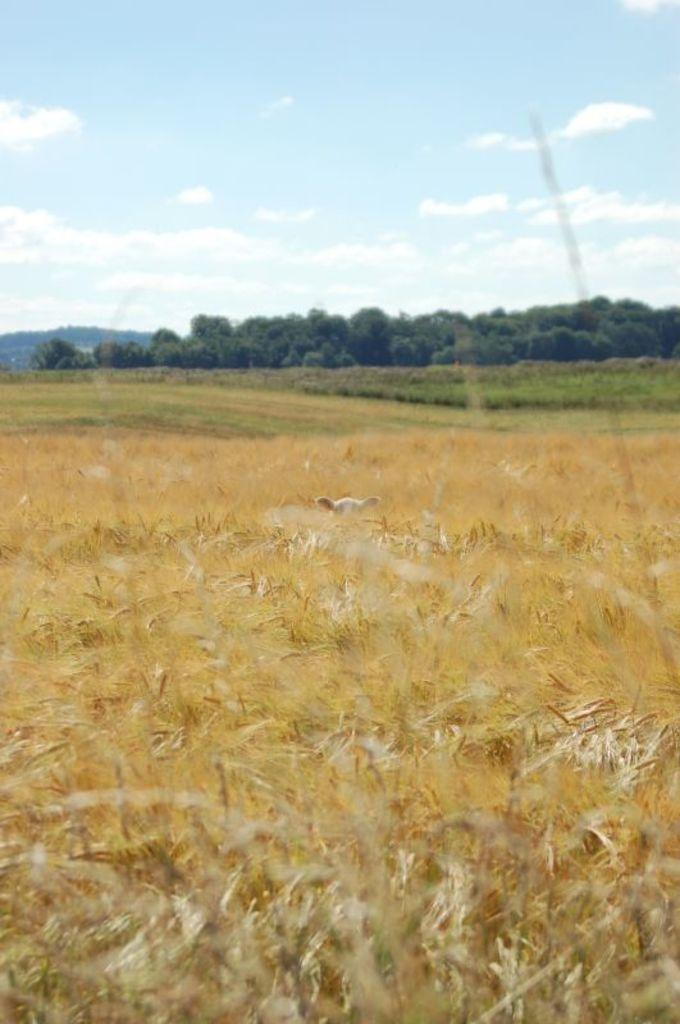What type of animal can be seen in the picture? There is a bird in the picture. What type of vegetation is present in the picture? There are crops, plants, and trees in the picture. What natural features can be seen in the backdrop of the picture? There are mountains in the backdrop of the picture. What is the condition of the sky in the picture? The sky is clear in the picture. Can you see the veins of the ant in the picture? There is no ant present in the picture, so its veins cannot be seen. 